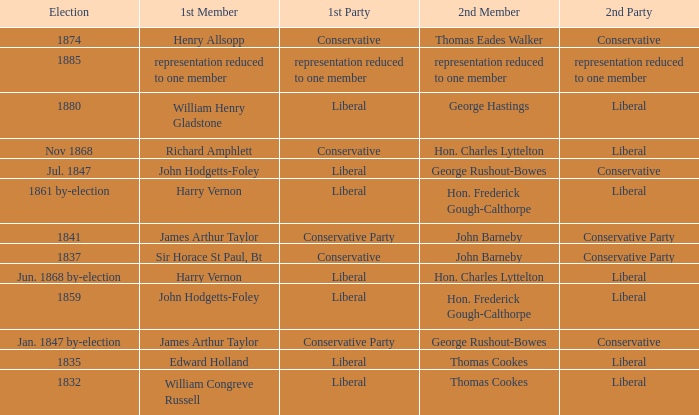What was the 2nd Party that had the 2nd Member John Barneby, when the 1st Party was Conservative? Conservative Party. 